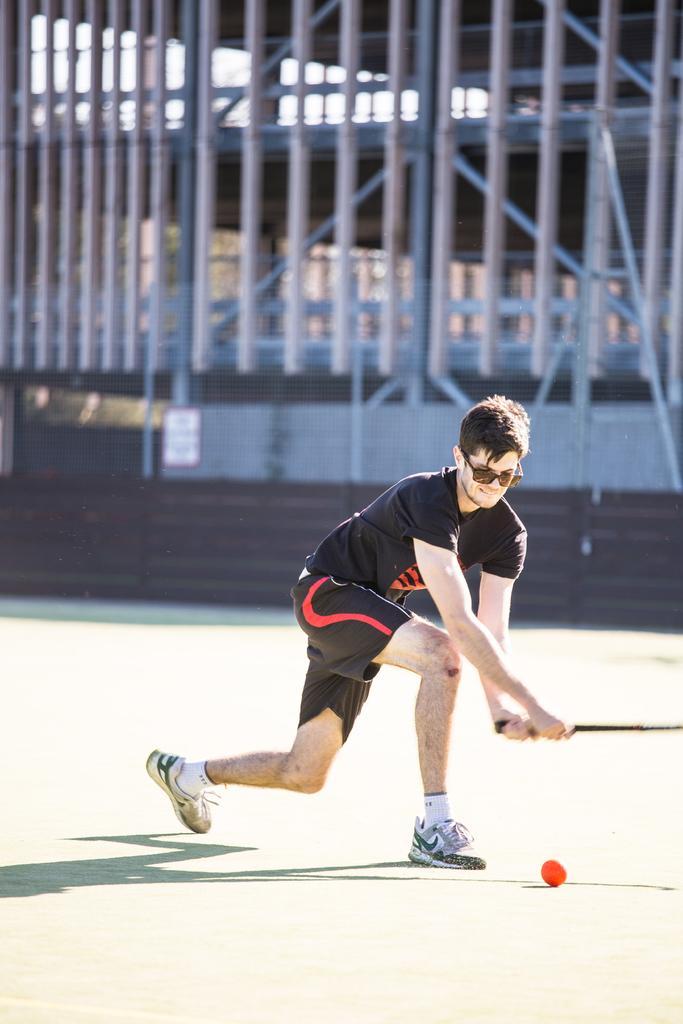Describe this image in one or two sentences. In the image there is a boy, he is about to hit a ball in front of him and the background of the boy is blur. 